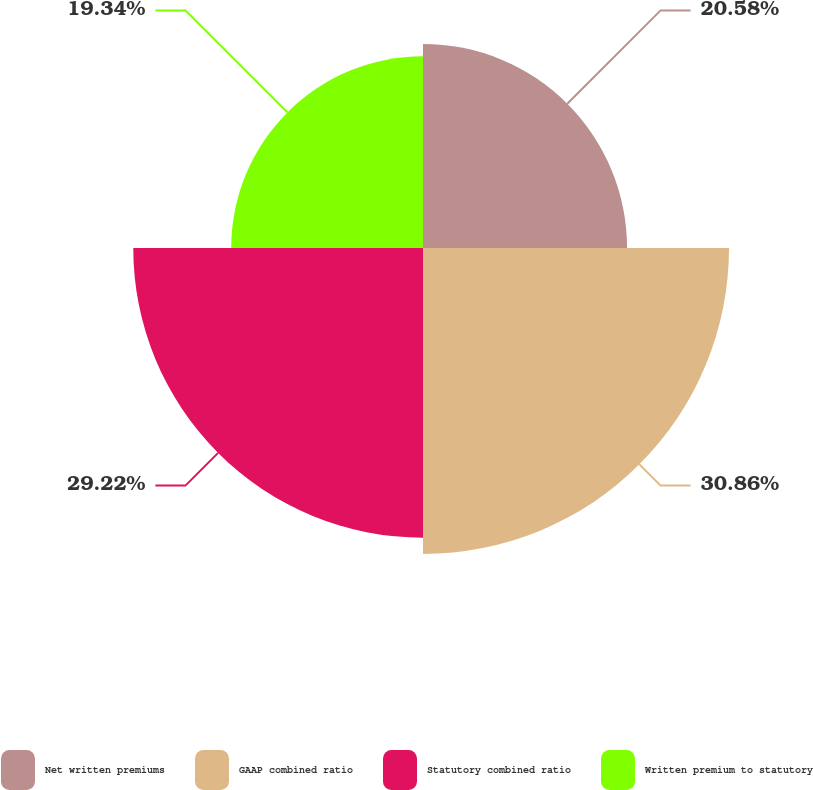Convert chart to OTSL. <chart><loc_0><loc_0><loc_500><loc_500><pie_chart><fcel>Net written premiums<fcel>GAAP combined ratio<fcel>Statutory combined ratio<fcel>Written premium to statutory<nl><fcel>20.58%<fcel>30.86%<fcel>29.22%<fcel>19.34%<nl></chart> 